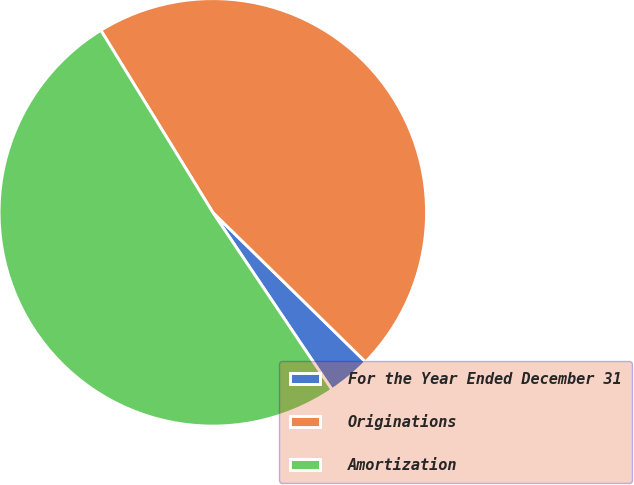Convert chart. <chart><loc_0><loc_0><loc_500><loc_500><pie_chart><fcel>For the Year Ended December 31<fcel>Originations<fcel>Amortization<nl><fcel>3.25%<fcel>46.11%<fcel>50.65%<nl></chart> 